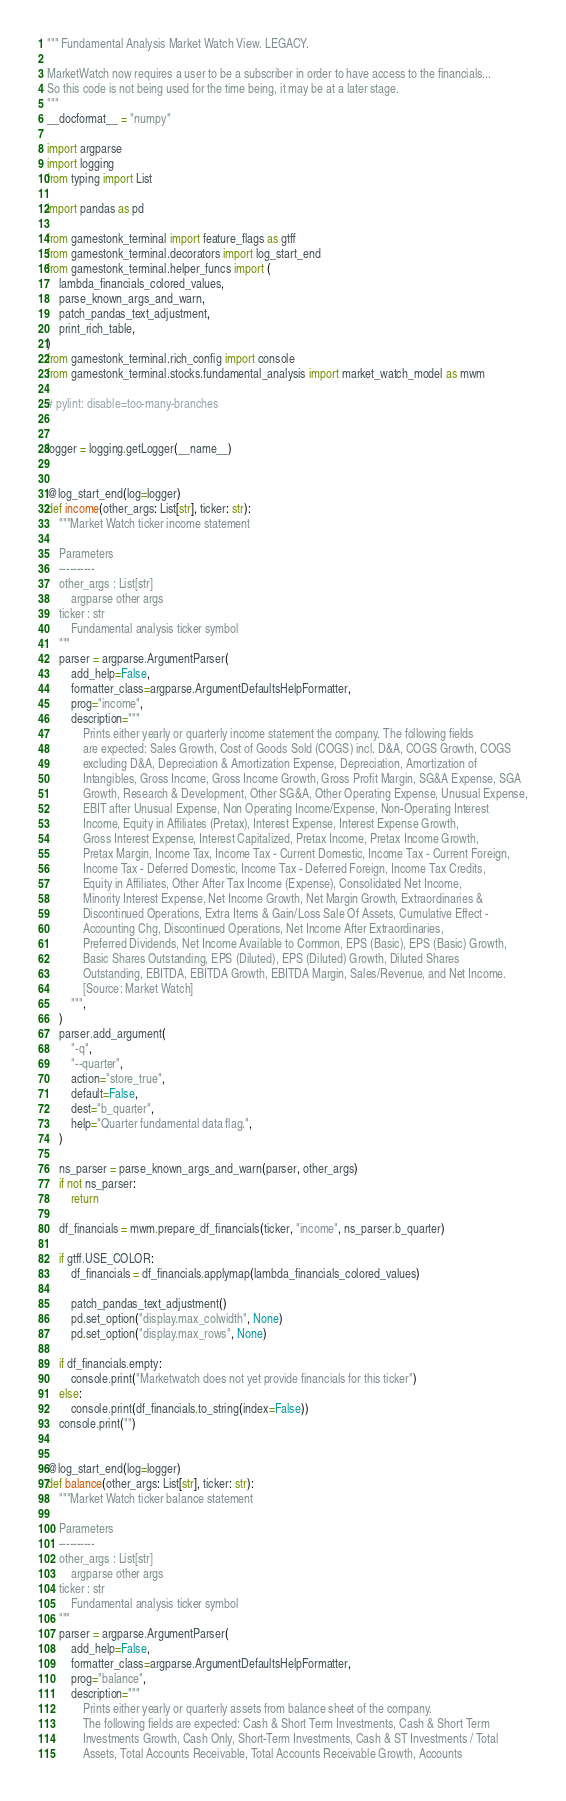<code> <loc_0><loc_0><loc_500><loc_500><_Python_>""" Fundamental Analysis Market Watch View. LEGACY.

MarketWatch now requires a user to be a subscriber in order to have access to the financials...
So this code is not being used for the time being, it may be at a later stage.
"""
__docformat__ = "numpy"

import argparse
import logging
from typing import List

import pandas as pd

from gamestonk_terminal import feature_flags as gtff
from gamestonk_terminal.decorators import log_start_end
from gamestonk_terminal.helper_funcs import (
    lambda_financials_colored_values,
    parse_known_args_and_warn,
    patch_pandas_text_adjustment,
    print_rich_table,
)
from gamestonk_terminal.rich_config import console
from gamestonk_terminal.stocks.fundamental_analysis import market_watch_model as mwm

# pylint: disable=too-many-branches


logger = logging.getLogger(__name__)


@log_start_end(log=logger)
def income(other_args: List[str], ticker: str):
    """Market Watch ticker income statement

    Parameters
    ----------
    other_args : List[str]
        argparse other args
    ticker : str
        Fundamental analysis ticker symbol
    """
    parser = argparse.ArgumentParser(
        add_help=False,
        formatter_class=argparse.ArgumentDefaultsHelpFormatter,
        prog="income",
        description="""
            Prints either yearly or quarterly income statement the company. The following fields
            are expected: Sales Growth, Cost of Goods Sold (COGS) incl. D&A, COGS Growth, COGS
            excluding D&A, Depreciation & Amortization Expense, Depreciation, Amortization of
            Intangibles, Gross Income, Gross Income Growth, Gross Profit Margin, SG&A Expense, SGA
            Growth, Research & Development, Other SG&A, Other Operating Expense, Unusual Expense,
            EBIT after Unusual Expense, Non Operating Income/Expense, Non-Operating Interest
            Income, Equity in Affiliates (Pretax), Interest Expense, Interest Expense Growth,
            Gross Interest Expense, Interest Capitalized, Pretax Income, Pretax Income Growth,
            Pretax Margin, Income Tax, Income Tax - Current Domestic, Income Tax - Current Foreign,
            Income Tax - Deferred Domestic, Income Tax - Deferred Foreign, Income Tax Credits,
            Equity in Affiliates, Other After Tax Income (Expense), Consolidated Net Income,
            Minority Interest Expense, Net Income Growth, Net Margin Growth, Extraordinaries &
            Discontinued Operations, Extra Items & Gain/Loss Sale Of Assets, Cumulative Effect -
            Accounting Chg, Discontinued Operations, Net Income After Extraordinaries,
            Preferred Dividends, Net Income Available to Common, EPS (Basic), EPS (Basic) Growth,
            Basic Shares Outstanding, EPS (Diluted), EPS (Diluted) Growth, Diluted Shares
            Outstanding, EBITDA, EBITDA Growth, EBITDA Margin, Sales/Revenue, and Net Income.
            [Source: Market Watch]
        """,
    )
    parser.add_argument(
        "-q",
        "--quarter",
        action="store_true",
        default=False,
        dest="b_quarter",
        help="Quarter fundamental data flag.",
    )

    ns_parser = parse_known_args_and_warn(parser, other_args)
    if not ns_parser:
        return

    df_financials = mwm.prepare_df_financials(ticker, "income", ns_parser.b_quarter)

    if gtff.USE_COLOR:
        df_financials = df_financials.applymap(lambda_financials_colored_values)

        patch_pandas_text_adjustment()
        pd.set_option("display.max_colwidth", None)
        pd.set_option("display.max_rows", None)

    if df_financials.empty:
        console.print("Marketwatch does not yet provide financials for this ticker")
    else:
        console.print(df_financials.to_string(index=False))
    console.print("")


@log_start_end(log=logger)
def balance(other_args: List[str], ticker: str):
    """Market Watch ticker balance statement

    Parameters
    ----------
    other_args : List[str]
        argparse other args
    ticker : str
        Fundamental analysis ticker symbol
    """
    parser = argparse.ArgumentParser(
        add_help=False,
        formatter_class=argparse.ArgumentDefaultsHelpFormatter,
        prog="balance",
        description="""
            Prints either yearly or quarterly assets from balance sheet of the company.
            The following fields are expected: Cash & Short Term Investments, Cash & Short Term
            Investments Growth, Cash Only, Short-Term Investments, Cash & ST Investments / Total
            Assets, Total Accounts Receivable, Total Accounts Receivable Growth, Accounts</code> 